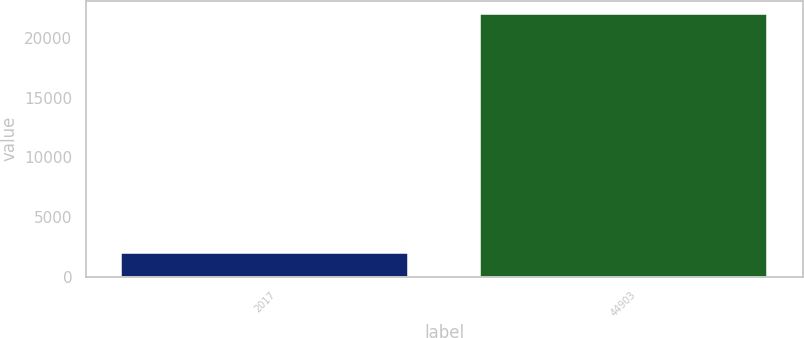Convert chart. <chart><loc_0><loc_0><loc_500><loc_500><bar_chart><fcel>2017<fcel>44903<nl><fcel>2015<fcel>22068<nl></chart> 